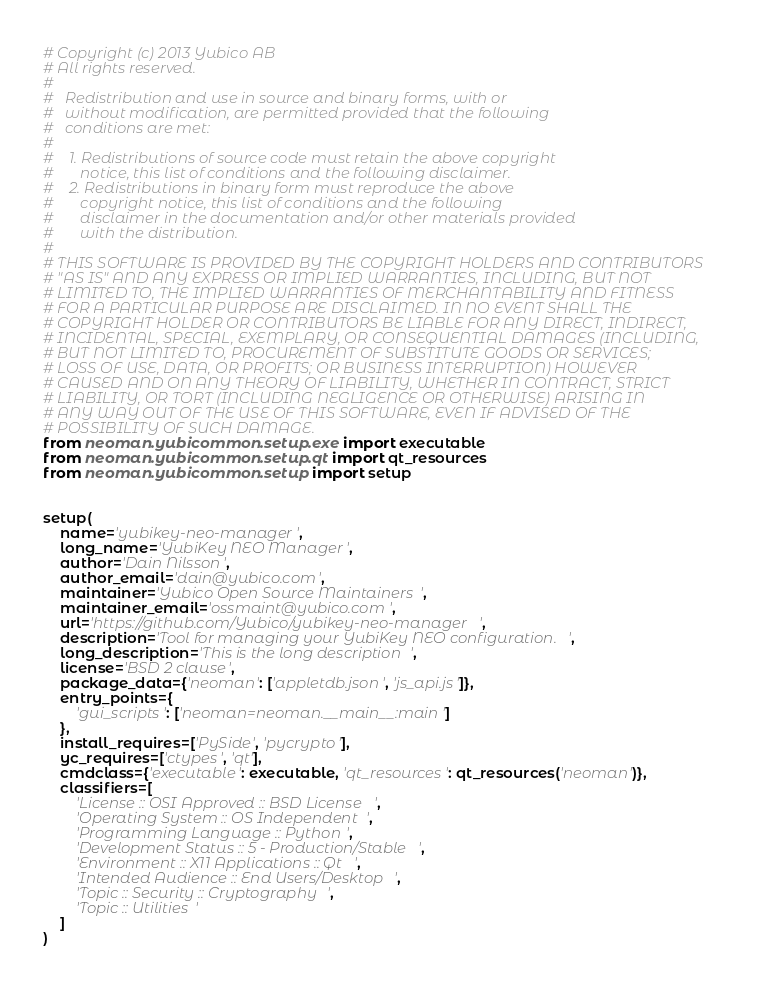Convert code to text. <code><loc_0><loc_0><loc_500><loc_500><_Python_># Copyright (c) 2013 Yubico AB
# All rights reserved.
#
#   Redistribution and use in source and binary forms, with or
#   without modification, are permitted provided that the following
#   conditions are met:
#
#    1. Redistributions of source code must retain the above copyright
#       notice, this list of conditions and the following disclaimer.
#    2. Redistributions in binary form must reproduce the above
#       copyright notice, this list of conditions and the following
#       disclaimer in the documentation and/or other materials provided
#       with the distribution.
#
# THIS SOFTWARE IS PROVIDED BY THE COPYRIGHT HOLDERS AND CONTRIBUTORS
# "AS IS" AND ANY EXPRESS OR IMPLIED WARRANTIES, INCLUDING, BUT NOT
# LIMITED TO, THE IMPLIED WARRANTIES OF MERCHANTABILITY AND FITNESS
# FOR A PARTICULAR PURPOSE ARE DISCLAIMED. IN NO EVENT SHALL THE
# COPYRIGHT HOLDER OR CONTRIBUTORS BE LIABLE FOR ANY DIRECT, INDIRECT,
# INCIDENTAL, SPECIAL, EXEMPLARY, OR CONSEQUENTIAL DAMAGES (INCLUDING,
# BUT NOT LIMITED TO, PROCUREMENT OF SUBSTITUTE GOODS OR SERVICES;
# LOSS OF USE, DATA, OR PROFITS; OR BUSINESS INTERRUPTION) HOWEVER
# CAUSED AND ON ANY THEORY OF LIABILITY, WHETHER IN CONTRACT, STRICT
# LIABILITY, OR TORT (INCLUDING NEGLIGENCE OR OTHERWISE) ARISING IN
# ANY WAY OUT OF THE USE OF THIS SOFTWARE, EVEN IF ADVISED OF THE
# POSSIBILITY OF SUCH DAMAGE.
from neoman.yubicommon.setup.exe import executable
from neoman.yubicommon.setup.qt import qt_resources
from neoman.yubicommon.setup import setup


setup(
    name='yubikey-neo-manager',
    long_name='YubiKey NEO Manager',
    author='Dain Nilsson',
    author_email='dain@yubico.com',
    maintainer='Yubico Open Source Maintainers',
    maintainer_email='ossmaint@yubico.com',
    url='https://github.com/Yubico/yubikey-neo-manager',
    description='Tool for managing your YubiKey NEO configuration.',
    long_description='This is the long description',
    license='BSD 2 clause',
    package_data={'neoman': ['appletdb.json', 'js_api.js']},
    entry_points={
        'gui_scripts': ['neoman=neoman.__main__:main']
    },
    install_requires=['PySide', 'pycrypto'],
    yc_requires=['ctypes', 'qt'],
    cmdclass={'executable': executable, 'qt_resources': qt_resources('neoman')},
    classifiers=[
        'License :: OSI Approved :: BSD License',
        'Operating System :: OS Independent',
        'Programming Language :: Python',
        'Development Status :: 5 - Production/Stable',
        'Environment :: X11 Applications :: Qt',
        'Intended Audience :: End Users/Desktop',
        'Topic :: Security :: Cryptography',
        'Topic :: Utilities'
    ]
)
</code> 